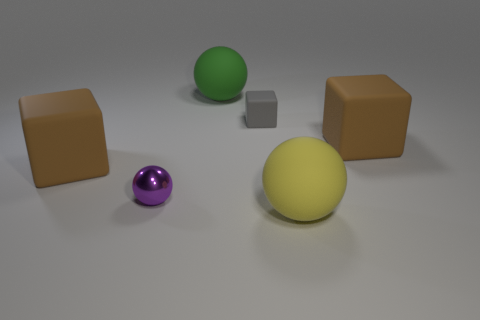What is the size of the yellow rubber thing that is the same shape as the green thing?
Make the answer very short. Large. How many things are both to the left of the gray block and behind the purple sphere?
Make the answer very short. 2. What color is the other large rubber object that is the same shape as the large green rubber object?
Offer a very short reply. Yellow. Is the number of small gray rubber blocks less than the number of large rubber cylinders?
Offer a very short reply. No. There is a gray matte thing; does it have the same size as the brown rubber thing on the left side of the big green rubber sphere?
Your response must be concise. No. There is a large matte thing that is to the right of the sphere that is in front of the purple sphere; what is its color?
Offer a very short reply. Brown. What number of things are either large matte objects on the right side of the big yellow rubber thing or large brown things to the right of the small gray rubber cube?
Keep it short and to the point. 1. Do the gray cube and the yellow rubber sphere have the same size?
Keep it short and to the point. No. Is there any other thing that is the same size as the green sphere?
Give a very brief answer. Yes. Does the yellow rubber object to the right of the green ball have the same shape as the big brown matte thing that is to the left of the large green object?
Offer a very short reply. No. 